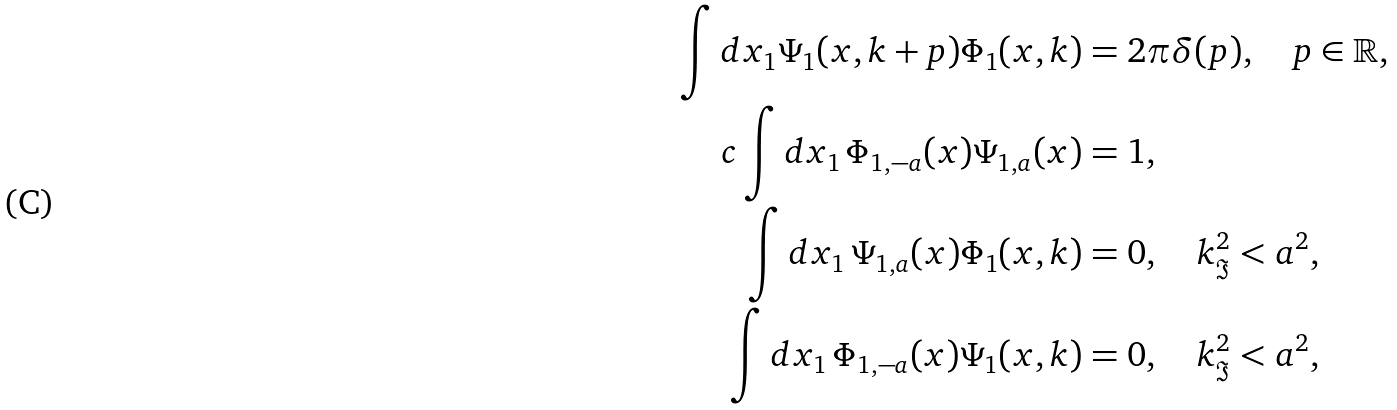<formula> <loc_0><loc_0><loc_500><loc_500>\int d x _ { 1 } \Psi _ { 1 } ( x , k + p ) \Phi _ { 1 } ( x , k ) & = 2 \pi \delta ( p ) , \quad p \in \mathbb { R } , \\ c \int d x _ { 1 } \, \Phi _ { 1 , - a } ( x ) \Psi _ { 1 , a } ( x ) & = 1 , \\ \int d x _ { 1 } \, \Psi _ { 1 , a } ( x ) \Phi _ { 1 } ( x , k ) & = 0 , \quad k _ { \Im } ^ { 2 } < a ^ { 2 } , \\ \int d x _ { 1 } \, \Phi _ { 1 , - a } ( x ) \Psi _ { 1 } ( x , k ) & = 0 , \quad k _ { \Im } ^ { 2 } < a ^ { 2 } ,</formula> 